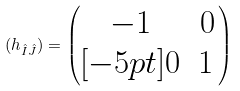<formula> <loc_0><loc_0><loc_500><loc_500>( h _ { \hat { I } \hat { J } } ) = \left ( \begin{matrix} - 1 & 0 \\ [ - 5 p t ] 0 & 1 \, \end{matrix} \right )</formula> 